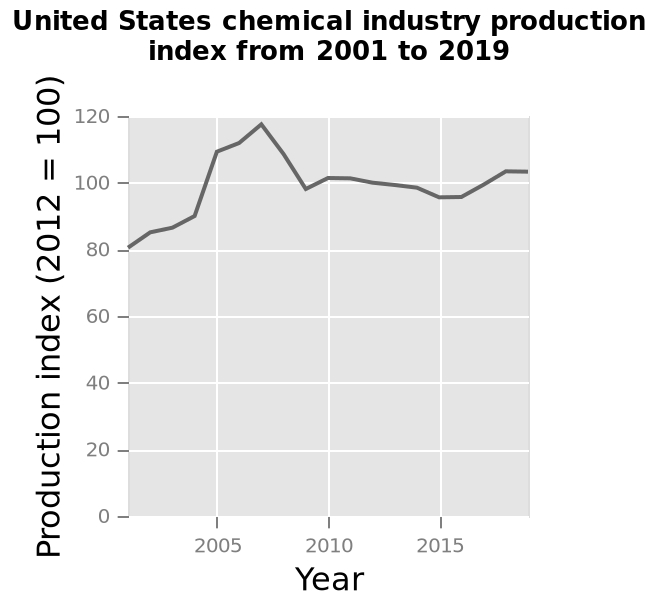<image>
What was the lowest production point of the US chemical industry since 2000? The lowest production point of the US chemical industry since 2000 was 80. In which year does the line plot start showing data? The line plot starts showing data from the year 2001. What does the x-axis represent? The x-axis represents the years from 2005 to 2015. 